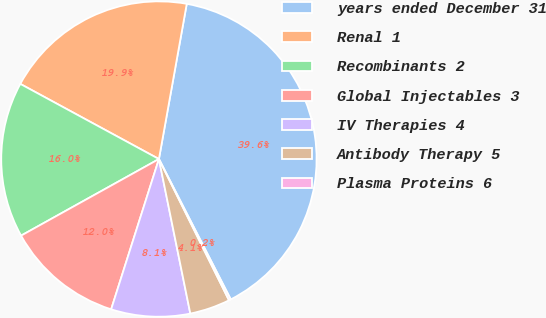Convert chart. <chart><loc_0><loc_0><loc_500><loc_500><pie_chart><fcel>years ended December 31<fcel>Renal 1<fcel>Recombinants 2<fcel>Global Injectables 3<fcel>IV Therapies 4<fcel>Antibody Therapy 5<fcel>Plasma Proteins 6<nl><fcel>39.65%<fcel>19.92%<fcel>15.98%<fcel>12.03%<fcel>8.09%<fcel>4.14%<fcel>0.2%<nl></chart> 